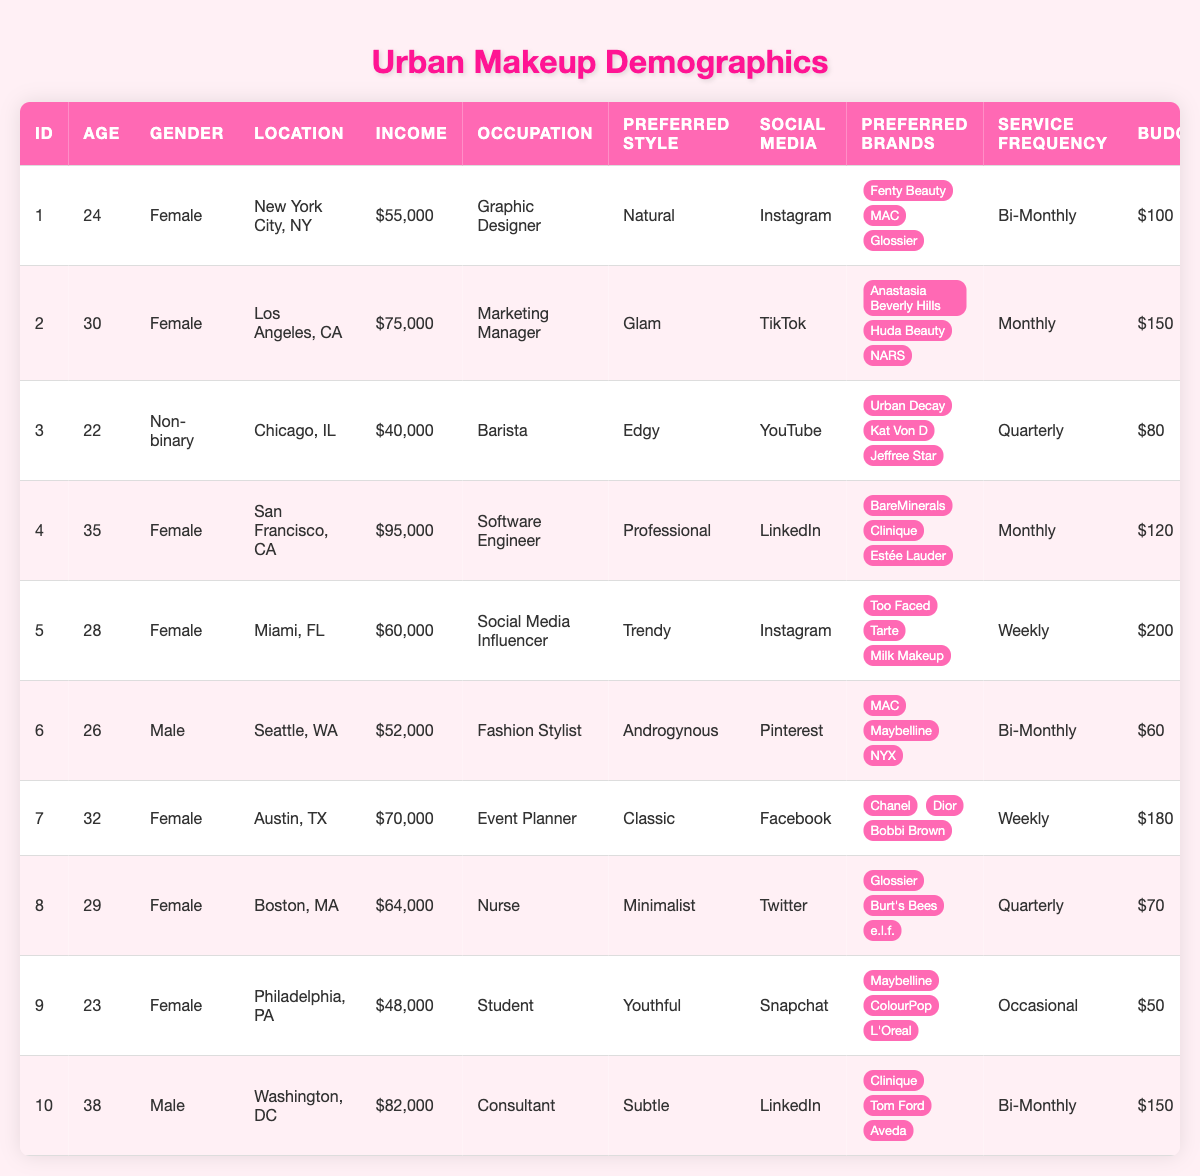What is the preferred makeup style of the customer in New York City? The customer in New York City (CustomerID 1) has their preferred makeup style listed as "Natural."
Answer: Natural What is the income of the marketing manager from Los Angeles? The marketing manager from Los Angeles (CustomerID 2) has an income of $75,000 listed in the table.
Answer: $75,000 How many customers have a preferred makeup style categorized as "Trendy"? There is one customer (CustomerID 5) whose preferred makeup style is categorized as "Trendy."
Answer: 1 Which social media platform is preferred by the individual from Chicago? The individual from Chicago (CustomerID 3) prefers YouTube as their social media platform.
Answer: YouTube Is there a male customer who prefers "Androgynous" makeup style, and if so, what is their budget? Yes, there is a male customer (CustomerID 6) who prefers an "Androgynous" makeup style and their budget is $60.
Answer: Yes, $60 What is the average budget of customers who prefer the "Glam" makeup style? There is one customer (CustomerID 2) who prefers the "Glam" makeup style with a budget of $150, so the average budget is $150/1 = $150.
Answer: $150 Which customer has the highest income and what is their occupation? The customer with the highest income is the software engineer from San Francisco (CustomerID 4) with an income of $95,000.
Answer: Software Engineer, $95,000 What is the frequency of services for the customer who is a social media influencer? The social media influencer from Miami (CustomerID 5) has a frequency of services listed as "Weekly."
Answer: Weekly How many customers prefer Instagram as their primary social media platform? Two customers (CustomerID 1 and 5) prefer Instagram as their primary social media platform.
Answer: 2 If we sum the budgets of all customers from Texas, what would it be? The budgets from Texas customers (CustomerIDs 7) sum up to $180.
Answer: $180 What percentage of customers are under the age of 30? There are four customers under the age of 30 (CustomerIDs 1, 3, 5, and 9) out of a total of 10 customers, so the percentage is (4/10)*100 = 40%.
Answer: 40% 